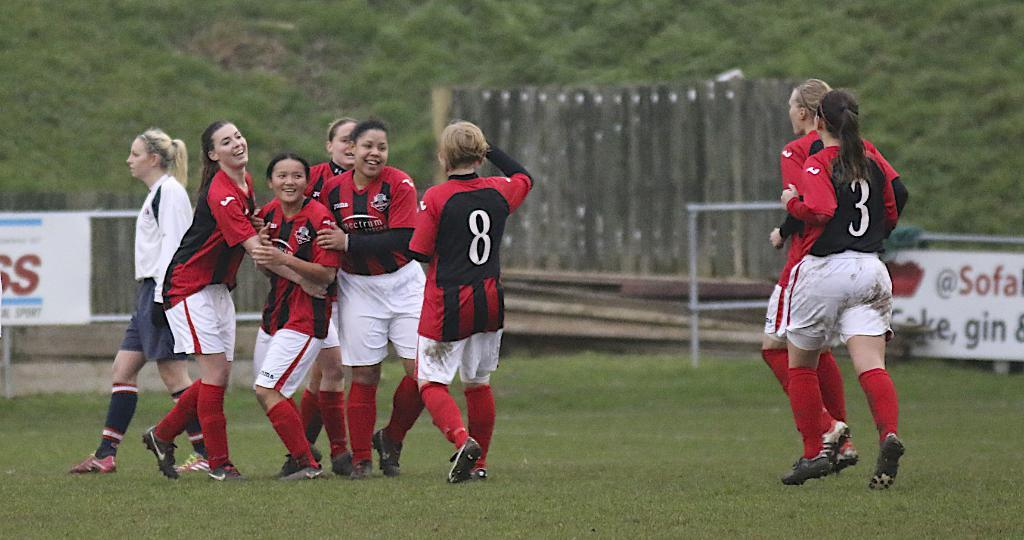How many people are present in the image? There are many people in the image. What is on the ground in the image? There is grass on the ground. What can be seen in the background of the image? There are banners and trees in the background. What type of barrier is present in the image? There is fencing in the image. What letter is written on the glass in the image? There is no glass or letter present in the image. 